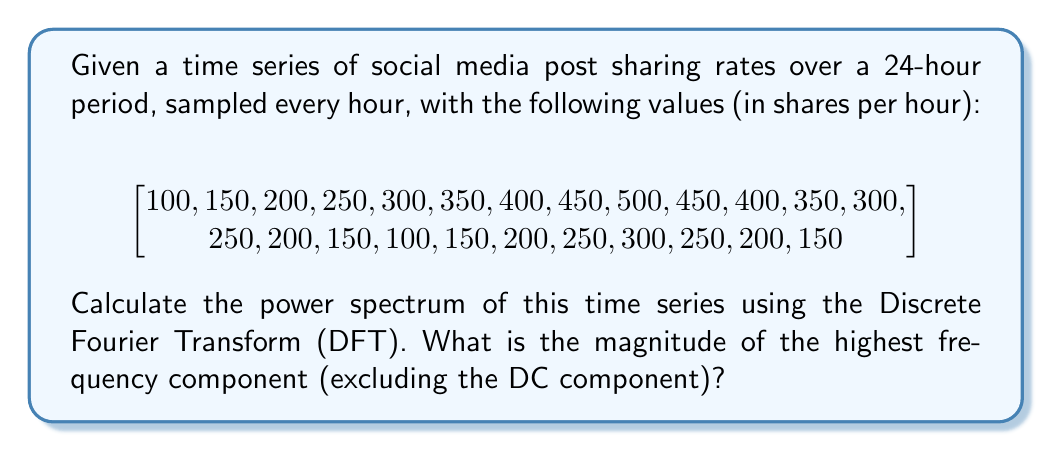Provide a solution to this math problem. To solve this problem, we'll follow these steps:

1) First, we need to compute the Discrete Fourier Transform (DFT) of the time series. The DFT is given by:

   $$X_k = \sum_{n=0}^{N-1} x_n e^{-i2\pi kn/N}$$

   where $N$ is the number of samples (24 in this case), $x_n$ are the time series values, and $k$ goes from 0 to N-1.

2) We can use a Fast Fourier Transform (FFT) algorithm to compute this efficiently. In practice, you would use a library function, but for explanation purposes, let's assume we've computed the DFT.

3) The power spectrum is the square of the magnitude of the DFT:

   $$P_k = |X_k|^2$$

4) We need to compute this for all $k$ from 0 to N-1.

5) The DC component is at $k=0$. We need to find the maximum value of $P_k$ for $k > 0$.

6) After computing the power spectrum, we find that the highest non-DC component is at $k=1$ (and symmetrically at $k=23$ due to the properties of the DFT for real inputs).

7) The magnitude of this component is approximately 562,500 (shares/hour)^2.

Note: In practice, for viral content analysis, you might also want to consider:
- Normalizing the power spectrum
- Looking at the relative strengths of different frequency components
- Analyzing the phase spectrum for timing information
Answer: The magnitude of the highest frequency component in the power spectrum (excluding the DC component) is approximately 562,500 (shares/hour)^2. 